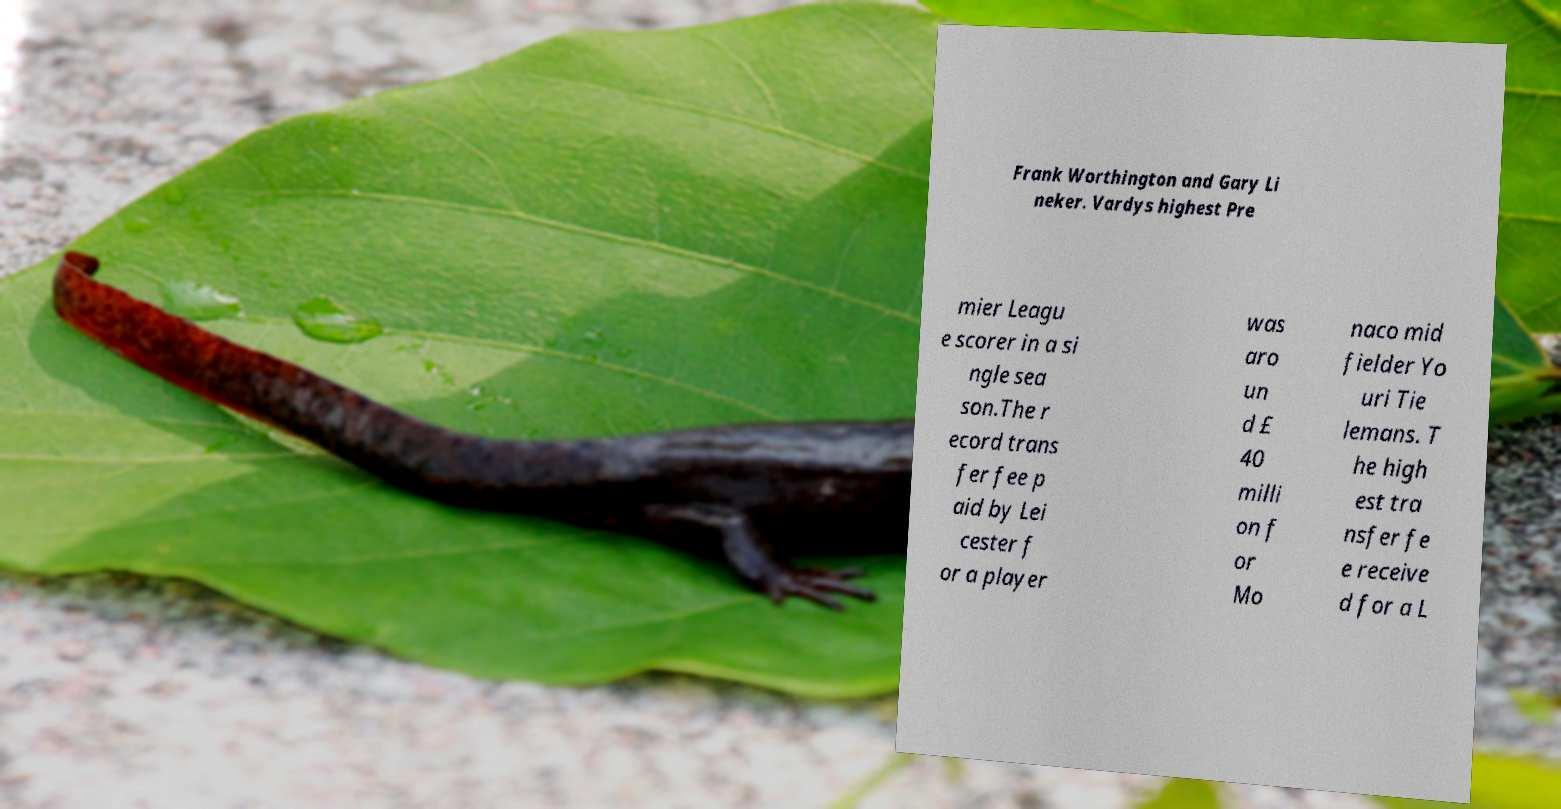There's text embedded in this image that I need extracted. Can you transcribe it verbatim? Frank Worthington and Gary Li neker. Vardys highest Pre mier Leagu e scorer in a si ngle sea son.The r ecord trans fer fee p aid by Lei cester f or a player was aro un d £ 40 milli on f or Mo naco mid fielder Yo uri Tie lemans. T he high est tra nsfer fe e receive d for a L 